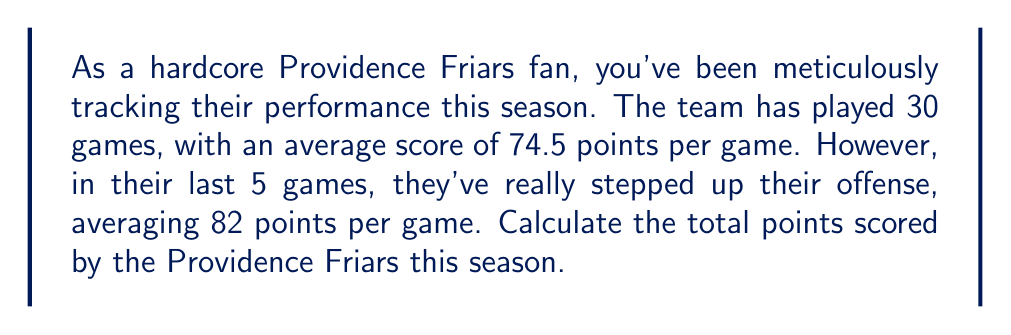Help me with this question. To solve this problem, we need to:
1. Calculate the points scored in the first 25 games
2. Calculate the points scored in the last 5 games
3. Add these two totals together

Let's break it down step-by-step:

1. Points scored in the first 25 games:
   $$ 25 \times 74.5 = 1862.5 \text{ points} $$

2. Points scored in the last 5 games:
   $$ 5 \times 82 = 410 \text{ points} $$

3. Total points for the season:
   $$ 1862.5 + 410 = 2272.5 \text{ points} $$

Since we're dealing with whole points in basketball, we'll round this to the nearest integer:

$$ \text{Total points} = \text{round}(2272.5) = 2273 \text{ points} $$
Answer: The Providence Friars scored a total of 2273 points this season. 